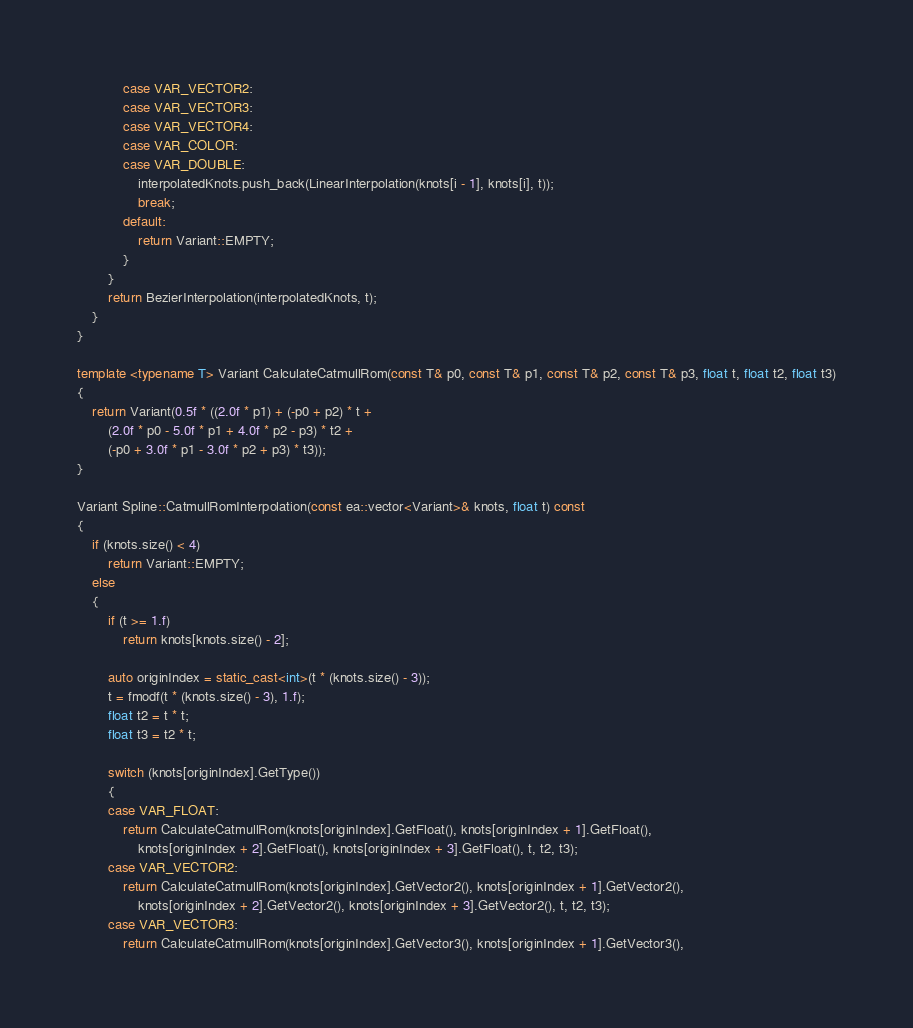<code> <loc_0><loc_0><loc_500><loc_500><_C++_>            case VAR_VECTOR2:
            case VAR_VECTOR3:
            case VAR_VECTOR4:
            case VAR_COLOR:
            case VAR_DOUBLE:
                interpolatedKnots.push_back(LinearInterpolation(knots[i - 1], knots[i], t));
                break;
            default:
                return Variant::EMPTY;
            }
        }
        return BezierInterpolation(interpolatedKnots, t);
    }
}

template <typename T> Variant CalculateCatmullRom(const T& p0, const T& p1, const T& p2, const T& p3, float t, float t2, float t3)
{
    return Variant(0.5f * ((2.0f * p1) + (-p0 + p2) * t +
        (2.0f * p0 - 5.0f * p1 + 4.0f * p2 - p3) * t2 +
        (-p0 + 3.0f * p1 - 3.0f * p2 + p3) * t3));
}

Variant Spline::CatmullRomInterpolation(const ea::vector<Variant>& knots, float t) const
{
    if (knots.size() < 4)
        return Variant::EMPTY;
    else
    {
        if (t >= 1.f)
            return knots[knots.size() - 2];

        auto originIndex = static_cast<int>(t * (knots.size() - 3));
        t = fmodf(t * (knots.size() - 3), 1.f);
        float t2 = t * t;
        float t3 = t2 * t;

        switch (knots[originIndex].GetType())
        {
        case VAR_FLOAT:
            return CalculateCatmullRom(knots[originIndex].GetFloat(), knots[originIndex + 1].GetFloat(),
                knots[originIndex + 2].GetFloat(), knots[originIndex + 3].GetFloat(), t, t2, t3);
        case VAR_VECTOR2:
            return CalculateCatmullRom(knots[originIndex].GetVector2(), knots[originIndex + 1].GetVector2(),
                knots[originIndex + 2].GetVector2(), knots[originIndex + 3].GetVector2(), t, t2, t3);
        case VAR_VECTOR3:
            return CalculateCatmullRom(knots[originIndex].GetVector3(), knots[originIndex + 1].GetVector3(),</code> 